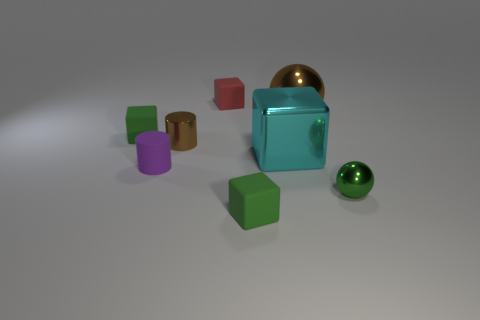Subtract all green cubes. How many were subtracted if there are1green cubes left? 1 Subtract all tiny red blocks. How many blocks are left? 3 Subtract 0 red cylinders. How many objects are left? 8 Subtract all cylinders. How many objects are left? 6 Subtract 1 cubes. How many cubes are left? 3 Subtract all purple cubes. Subtract all gray cylinders. How many cubes are left? 4 Subtract all cyan cylinders. How many brown blocks are left? 0 Subtract all cylinders. Subtract all cyan blocks. How many objects are left? 5 Add 8 brown shiny spheres. How many brown shiny spheres are left? 9 Add 5 big brown objects. How many big brown objects exist? 6 